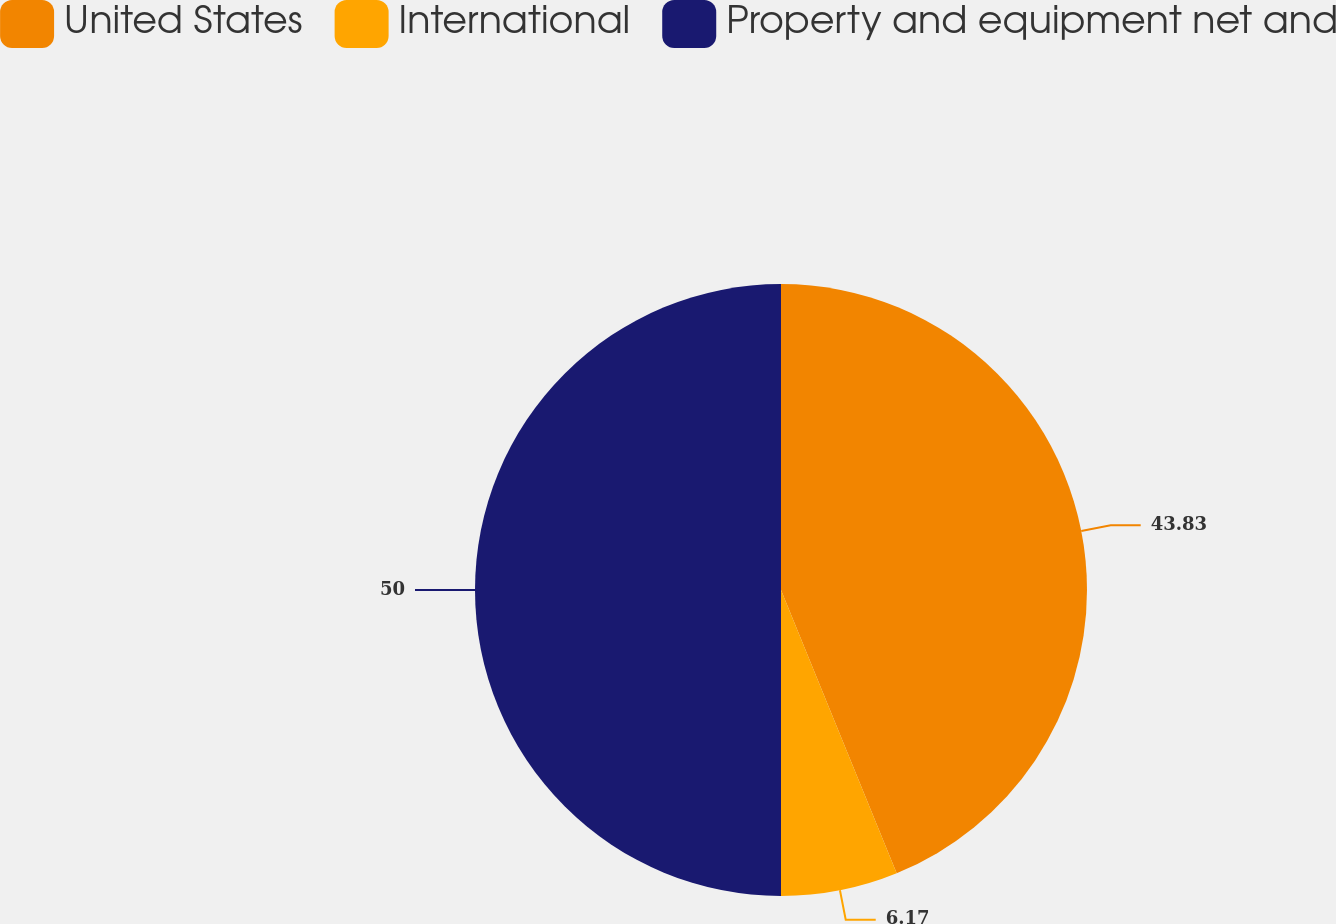Convert chart. <chart><loc_0><loc_0><loc_500><loc_500><pie_chart><fcel>United States<fcel>International<fcel>Property and equipment net and<nl><fcel>43.83%<fcel>6.17%<fcel>50.0%<nl></chart> 